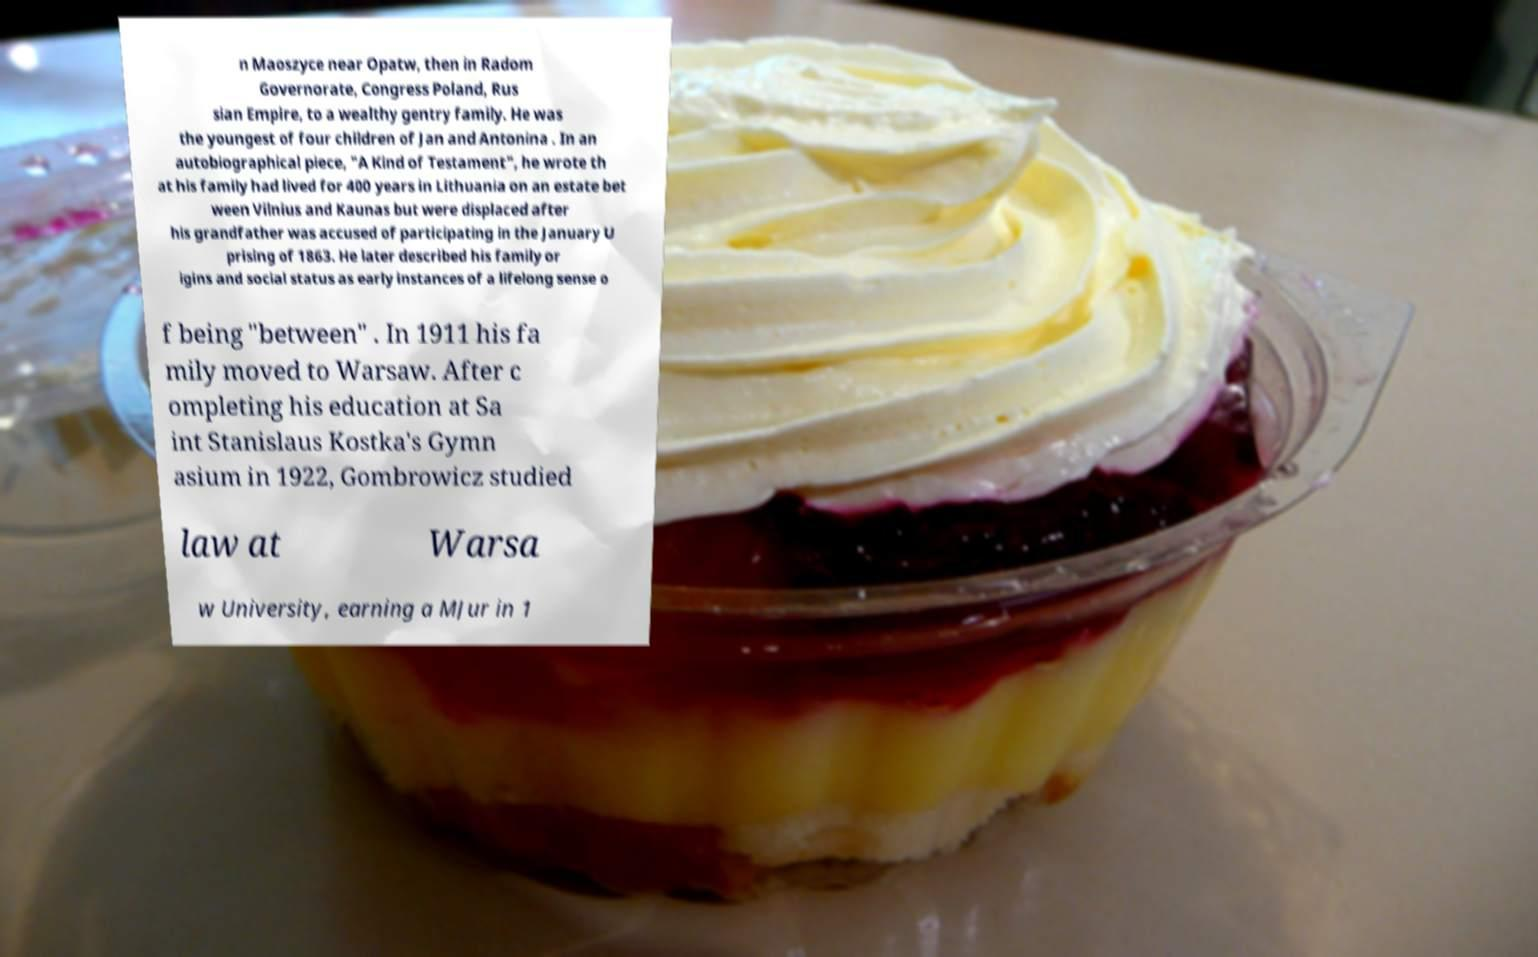I need the written content from this picture converted into text. Can you do that? n Maoszyce near Opatw, then in Radom Governorate, Congress Poland, Rus sian Empire, to a wealthy gentry family. He was the youngest of four children of Jan and Antonina . In an autobiographical piece, "A Kind of Testament", he wrote th at his family had lived for 400 years in Lithuania on an estate bet ween Vilnius and Kaunas but were displaced after his grandfather was accused of participating in the January U prising of 1863. He later described his family or igins and social status as early instances of a lifelong sense o f being "between" . In 1911 his fa mily moved to Warsaw. After c ompleting his education at Sa int Stanislaus Kostka's Gymn asium in 1922, Gombrowicz studied law at Warsa w University, earning a MJur in 1 